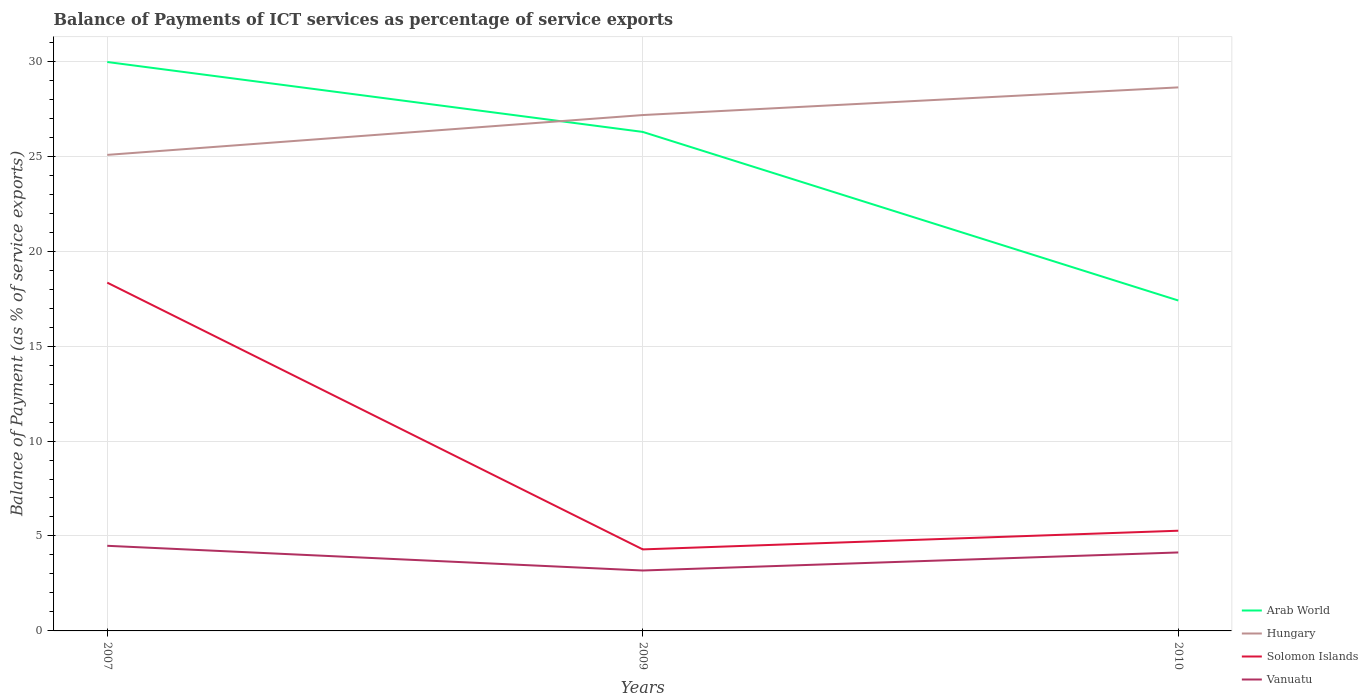Is the number of lines equal to the number of legend labels?
Your answer should be compact. Yes. Across all years, what is the maximum balance of payments of ICT services in Vanuatu?
Offer a very short reply. 3.18. What is the total balance of payments of ICT services in Vanuatu in the graph?
Give a very brief answer. -0.95. What is the difference between the highest and the second highest balance of payments of ICT services in Hungary?
Provide a short and direct response. 3.55. What is the difference between the highest and the lowest balance of payments of ICT services in Arab World?
Offer a terse response. 2. How many years are there in the graph?
Your answer should be compact. 3. What is the difference between two consecutive major ticks on the Y-axis?
Provide a short and direct response. 5. Are the values on the major ticks of Y-axis written in scientific E-notation?
Your answer should be compact. No. Does the graph contain grids?
Your answer should be compact. Yes. Where does the legend appear in the graph?
Offer a terse response. Bottom right. How many legend labels are there?
Keep it short and to the point. 4. How are the legend labels stacked?
Your answer should be very brief. Vertical. What is the title of the graph?
Offer a very short reply. Balance of Payments of ICT services as percentage of service exports. What is the label or title of the Y-axis?
Make the answer very short. Balance of Payment (as % of service exports). What is the Balance of Payment (as % of service exports) of Arab World in 2007?
Make the answer very short. 29.96. What is the Balance of Payment (as % of service exports) of Hungary in 2007?
Keep it short and to the point. 25.07. What is the Balance of Payment (as % of service exports) of Solomon Islands in 2007?
Your answer should be compact. 18.34. What is the Balance of Payment (as % of service exports) of Vanuatu in 2007?
Provide a short and direct response. 4.48. What is the Balance of Payment (as % of service exports) in Arab World in 2009?
Ensure brevity in your answer.  26.28. What is the Balance of Payment (as % of service exports) of Hungary in 2009?
Ensure brevity in your answer.  27.17. What is the Balance of Payment (as % of service exports) of Solomon Islands in 2009?
Keep it short and to the point. 4.29. What is the Balance of Payment (as % of service exports) of Vanuatu in 2009?
Ensure brevity in your answer.  3.18. What is the Balance of Payment (as % of service exports) in Arab World in 2010?
Make the answer very short. 17.4. What is the Balance of Payment (as % of service exports) in Hungary in 2010?
Your response must be concise. 28.62. What is the Balance of Payment (as % of service exports) of Solomon Islands in 2010?
Your response must be concise. 5.28. What is the Balance of Payment (as % of service exports) of Vanuatu in 2010?
Make the answer very short. 4.13. Across all years, what is the maximum Balance of Payment (as % of service exports) in Arab World?
Make the answer very short. 29.96. Across all years, what is the maximum Balance of Payment (as % of service exports) in Hungary?
Your answer should be compact. 28.62. Across all years, what is the maximum Balance of Payment (as % of service exports) in Solomon Islands?
Keep it short and to the point. 18.34. Across all years, what is the maximum Balance of Payment (as % of service exports) of Vanuatu?
Your response must be concise. 4.48. Across all years, what is the minimum Balance of Payment (as % of service exports) in Arab World?
Ensure brevity in your answer.  17.4. Across all years, what is the minimum Balance of Payment (as % of service exports) of Hungary?
Offer a terse response. 25.07. Across all years, what is the minimum Balance of Payment (as % of service exports) in Solomon Islands?
Your response must be concise. 4.29. Across all years, what is the minimum Balance of Payment (as % of service exports) in Vanuatu?
Your answer should be compact. 3.18. What is the total Balance of Payment (as % of service exports) of Arab World in the graph?
Offer a very short reply. 73.64. What is the total Balance of Payment (as % of service exports) in Hungary in the graph?
Your answer should be compact. 80.86. What is the total Balance of Payment (as % of service exports) of Solomon Islands in the graph?
Provide a short and direct response. 27.91. What is the total Balance of Payment (as % of service exports) in Vanuatu in the graph?
Make the answer very short. 11.8. What is the difference between the Balance of Payment (as % of service exports) in Arab World in 2007 and that in 2009?
Provide a short and direct response. 3.68. What is the difference between the Balance of Payment (as % of service exports) of Hungary in 2007 and that in 2009?
Ensure brevity in your answer.  -2.1. What is the difference between the Balance of Payment (as % of service exports) of Solomon Islands in 2007 and that in 2009?
Provide a succinct answer. 14.05. What is the difference between the Balance of Payment (as % of service exports) of Vanuatu in 2007 and that in 2009?
Provide a succinct answer. 1.3. What is the difference between the Balance of Payment (as % of service exports) in Arab World in 2007 and that in 2010?
Your answer should be very brief. 12.56. What is the difference between the Balance of Payment (as % of service exports) of Hungary in 2007 and that in 2010?
Your answer should be very brief. -3.55. What is the difference between the Balance of Payment (as % of service exports) of Solomon Islands in 2007 and that in 2010?
Provide a succinct answer. 13.06. What is the difference between the Balance of Payment (as % of service exports) in Vanuatu in 2007 and that in 2010?
Offer a terse response. 0.35. What is the difference between the Balance of Payment (as % of service exports) in Arab World in 2009 and that in 2010?
Provide a short and direct response. 8.88. What is the difference between the Balance of Payment (as % of service exports) in Hungary in 2009 and that in 2010?
Give a very brief answer. -1.46. What is the difference between the Balance of Payment (as % of service exports) in Solomon Islands in 2009 and that in 2010?
Your answer should be compact. -0.98. What is the difference between the Balance of Payment (as % of service exports) in Vanuatu in 2009 and that in 2010?
Offer a very short reply. -0.95. What is the difference between the Balance of Payment (as % of service exports) in Arab World in 2007 and the Balance of Payment (as % of service exports) in Hungary in 2009?
Provide a short and direct response. 2.79. What is the difference between the Balance of Payment (as % of service exports) in Arab World in 2007 and the Balance of Payment (as % of service exports) in Solomon Islands in 2009?
Give a very brief answer. 25.67. What is the difference between the Balance of Payment (as % of service exports) in Arab World in 2007 and the Balance of Payment (as % of service exports) in Vanuatu in 2009?
Make the answer very short. 26.78. What is the difference between the Balance of Payment (as % of service exports) of Hungary in 2007 and the Balance of Payment (as % of service exports) of Solomon Islands in 2009?
Give a very brief answer. 20.78. What is the difference between the Balance of Payment (as % of service exports) of Hungary in 2007 and the Balance of Payment (as % of service exports) of Vanuatu in 2009?
Offer a very short reply. 21.89. What is the difference between the Balance of Payment (as % of service exports) in Solomon Islands in 2007 and the Balance of Payment (as % of service exports) in Vanuatu in 2009?
Provide a succinct answer. 15.16. What is the difference between the Balance of Payment (as % of service exports) of Arab World in 2007 and the Balance of Payment (as % of service exports) of Hungary in 2010?
Keep it short and to the point. 1.34. What is the difference between the Balance of Payment (as % of service exports) of Arab World in 2007 and the Balance of Payment (as % of service exports) of Solomon Islands in 2010?
Your response must be concise. 24.68. What is the difference between the Balance of Payment (as % of service exports) of Arab World in 2007 and the Balance of Payment (as % of service exports) of Vanuatu in 2010?
Give a very brief answer. 25.83. What is the difference between the Balance of Payment (as % of service exports) of Hungary in 2007 and the Balance of Payment (as % of service exports) of Solomon Islands in 2010?
Offer a terse response. 19.79. What is the difference between the Balance of Payment (as % of service exports) of Hungary in 2007 and the Balance of Payment (as % of service exports) of Vanuatu in 2010?
Offer a terse response. 20.94. What is the difference between the Balance of Payment (as % of service exports) in Solomon Islands in 2007 and the Balance of Payment (as % of service exports) in Vanuatu in 2010?
Ensure brevity in your answer.  14.21. What is the difference between the Balance of Payment (as % of service exports) in Arab World in 2009 and the Balance of Payment (as % of service exports) in Hungary in 2010?
Offer a terse response. -2.35. What is the difference between the Balance of Payment (as % of service exports) in Arab World in 2009 and the Balance of Payment (as % of service exports) in Solomon Islands in 2010?
Give a very brief answer. 21. What is the difference between the Balance of Payment (as % of service exports) of Arab World in 2009 and the Balance of Payment (as % of service exports) of Vanuatu in 2010?
Make the answer very short. 22.15. What is the difference between the Balance of Payment (as % of service exports) in Hungary in 2009 and the Balance of Payment (as % of service exports) in Solomon Islands in 2010?
Offer a very short reply. 21.89. What is the difference between the Balance of Payment (as % of service exports) in Hungary in 2009 and the Balance of Payment (as % of service exports) in Vanuatu in 2010?
Give a very brief answer. 23.03. What is the difference between the Balance of Payment (as % of service exports) of Solomon Islands in 2009 and the Balance of Payment (as % of service exports) of Vanuatu in 2010?
Offer a terse response. 0.16. What is the average Balance of Payment (as % of service exports) of Arab World per year?
Keep it short and to the point. 24.55. What is the average Balance of Payment (as % of service exports) of Hungary per year?
Ensure brevity in your answer.  26.95. What is the average Balance of Payment (as % of service exports) in Solomon Islands per year?
Your answer should be very brief. 9.3. What is the average Balance of Payment (as % of service exports) of Vanuatu per year?
Provide a short and direct response. 3.93. In the year 2007, what is the difference between the Balance of Payment (as % of service exports) in Arab World and Balance of Payment (as % of service exports) in Hungary?
Give a very brief answer. 4.89. In the year 2007, what is the difference between the Balance of Payment (as % of service exports) of Arab World and Balance of Payment (as % of service exports) of Solomon Islands?
Your answer should be very brief. 11.62. In the year 2007, what is the difference between the Balance of Payment (as % of service exports) of Arab World and Balance of Payment (as % of service exports) of Vanuatu?
Give a very brief answer. 25.48. In the year 2007, what is the difference between the Balance of Payment (as % of service exports) in Hungary and Balance of Payment (as % of service exports) in Solomon Islands?
Your answer should be compact. 6.73. In the year 2007, what is the difference between the Balance of Payment (as % of service exports) of Hungary and Balance of Payment (as % of service exports) of Vanuatu?
Provide a short and direct response. 20.59. In the year 2007, what is the difference between the Balance of Payment (as % of service exports) in Solomon Islands and Balance of Payment (as % of service exports) in Vanuatu?
Give a very brief answer. 13.86. In the year 2009, what is the difference between the Balance of Payment (as % of service exports) in Arab World and Balance of Payment (as % of service exports) in Hungary?
Provide a succinct answer. -0.89. In the year 2009, what is the difference between the Balance of Payment (as % of service exports) in Arab World and Balance of Payment (as % of service exports) in Solomon Islands?
Give a very brief answer. 21.98. In the year 2009, what is the difference between the Balance of Payment (as % of service exports) of Arab World and Balance of Payment (as % of service exports) of Vanuatu?
Keep it short and to the point. 23.1. In the year 2009, what is the difference between the Balance of Payment (as % of service exports) of Hungary and Balance of Payment (as % of service exports) of Solomon Islands?
Give a very brief answer. 22.87. In the year 2009, what is the difference between the Balance of Payment (as % of service exports) in Hungary and Balance of Payment (as % of service exports) in Vanuatu?
Provide a short and direct response. 23.98. In the year 2009, what is the difference between the Balance of Payment (as % of service exports) in Solomon Islands and Balance of Payment (as % of service exports) in Vanuatu?
Give a very brief answer. 1.11. In the year 2010, what is the difference between the Balance of Payment (as % of service exports) in Arab World and Balance of Payment (as % of service exports) in Hungary?
Ensure brevity in your answer.  -11.22. In the year 2010, what is the difference between the Balance of Payment (as % of service exports) in Arab World and Balance of Payment (as % of service exports) in Solomon Islands?
Offer a terse response. 12.12. In the year 2010, what is the difference between the Balance of Payment (as % of service exports) of Arab World and Balance of Payment (as % of service exports) of Vanuatu?
Offer a terse response. 13.27. In the year 2010, what is the difference between the Balance of Payment (as % of service exports) of Hungary and Balance of Payment (as % of service exports) of Solomon Islands?
Make the answer very short. 23.35. In the year 2010, what is the difference between the Balance of Payment (as % of service exports) in Hungary and Balance of Payment (as % of service exports) in Vanuatu?
Your answer should be very brief. 24.49. In the year 2010, what is the difference between the Balance of Payment (as % of service exports) of Solomon Islands and Balance of Payment (as % of service exports) of Vanuatu?
Offer a very short reply. 1.14. What is the ratio of the Balance of Payment (as % of service exports) of Arab World in 2007 to that in 2009?
Give a very brief answer. 1.14. What is the ratio of the Balance of Payment (as % of service exports) of Hungary in 2007 to that in 2009?
Provide a short and direct response. 0.92. What is the ratio of the Balance of Payment (as % of service exports) of Solomon Islands in 2007 to that in 2009?
Offer a very short reply. 4.27. What is the ratio of the Balance of Payment (as % of service exports) of Vanuatu in 2007 to that in 2009?
Provide a short and direct response. 1.41. What is the ratio of the Balance of Payment (as % of service exports) of Arab World in 2007 to that in 2010?
Offer a terse response. 1.72. What is the ratio of the Balance of Payment (as % of service exports) of Hungary in 2007 to that in 2010?
Keep it short and to the point. 0.88. What is the ratio of the Balance of Payment (as % of service exports) in Solomon Islands in 2007 to that in 2010?
Ensure brevity in your answer.  3.48. What is the ratio of the Balance of Payment (as % of service exports) of Vanuatu in 2007 to that in 2010?
Offer a very short reply. 1.08. What is the ratio of the Balance of Payment (as % of service exports) in Arab World in 2009 to that in 2010?
Make the answer very short. 1.51. What is the ratio of the Balance of Payment (as % of service exports) in Hungary in 2009 to that in 2010?
Provide a succinct answer. 0.95. What is the ratio of the Balance of Payment (as % of service exports) in Solomon Islands in 2009 to that in 2010?
Make the answer very short. 0.81. What is the ratio of the Balance of Payment (as % of service exports) in Vanuatu in 2009 to that in 2010?
Offer a terse response. 0.77. What is the difference between the highest and the second highest Balance of Payment (as % of service exports) of Arab World?
Offer a terse response. 3.68. What is the difference between the highest and the second highest Balance of Payment (as % of service exports) in Hungary?
Make the answer very short. 1.46. What is the difference between the highest and the second highest Balance of Payment (as % of service exports) in Solomon Islands?
Offer a terse response. 13.06. What is the difference between the highest and the second highest Balance of Payment (as % of service exports) in Vanuatu?
Your response must be concise. 0.35. What is the difference between the highest and the lowest Balance of Payment (as % of service exports) in Arab World?
Your answer should be very brief. 12.56. What is the difference between the highest and the lowest Balance of Payment (as % of service exports) of Hungary?
Offer a very short reply. 3.55. What is the difference between the highest and the lowest Balance of Payment (as % of service exports) in Solomon Islands?
Ensure brevity in your answer.  14.05. What is the difference between the highest and the lowest Balance of Payment (as % of service exports) of Vanuatu?
Provide a succinct answer. 1.3. 